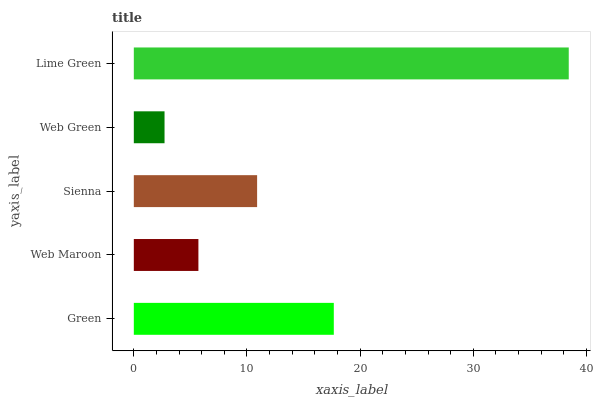Is Web Green the minimum?
Answer yes or no. Yes. Is Lime Green the maximum?
Answer yes or no. Yes. Is Web Maroon the minimum?
Answer yes or no. No. Is Web Maroon the maximum?
Answer yes or no. No. Is Green greater than Web Maroon?
Answer yes or no. Yes. Is Web Maroon less than Green?
Answer yes or no. Yes. Is Web Maroon greater than Green?
Answer yes or no. No. Is Green less than Web Maroon?
Answer yes or no. No. Is Sienna the high median?
Answer yes or no. Yes. Is Sienna the low median?
Answer yes or no. Yes. Is Lime Green the high median?
Answer yes or no. No. Is Lime Green the low median?
Answer yes or no. No. 